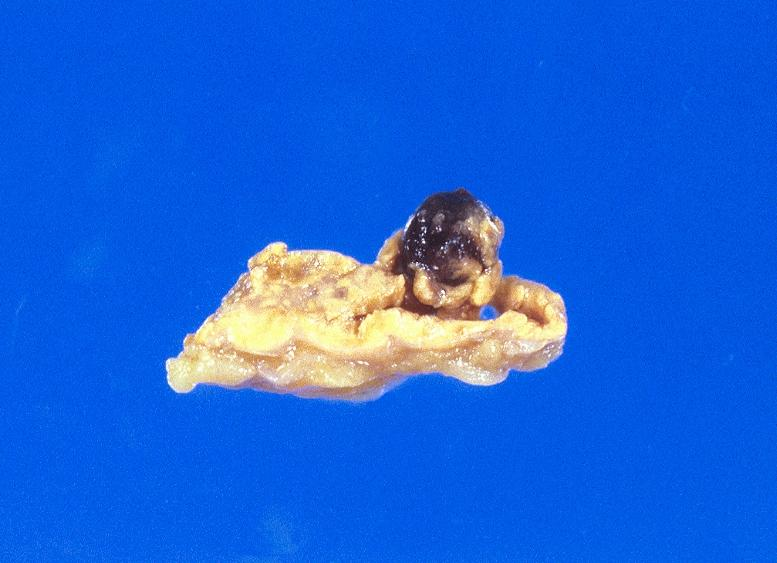what is present?
Answer the question using a single word or phrase. Muscle 